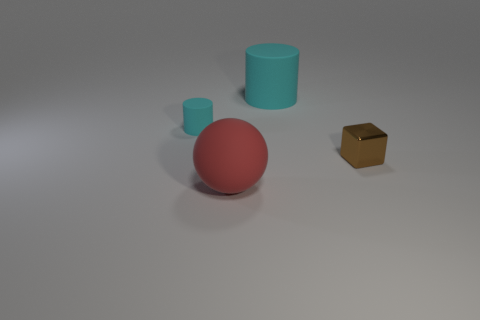Add 2 small brown shiny cubes. How many objects exist? 6 Subtract all cubes. How many objects are left? 3 Subtract all cyan objects. Subtract all yellow spheres. How many objects are left? 2 Add 3 large matte spheres. How many large matte spheres are left? 4 Add 2 red objects. How many red objects exist? 3 Subtract 1 brown cubes. How many objects are left? 3 